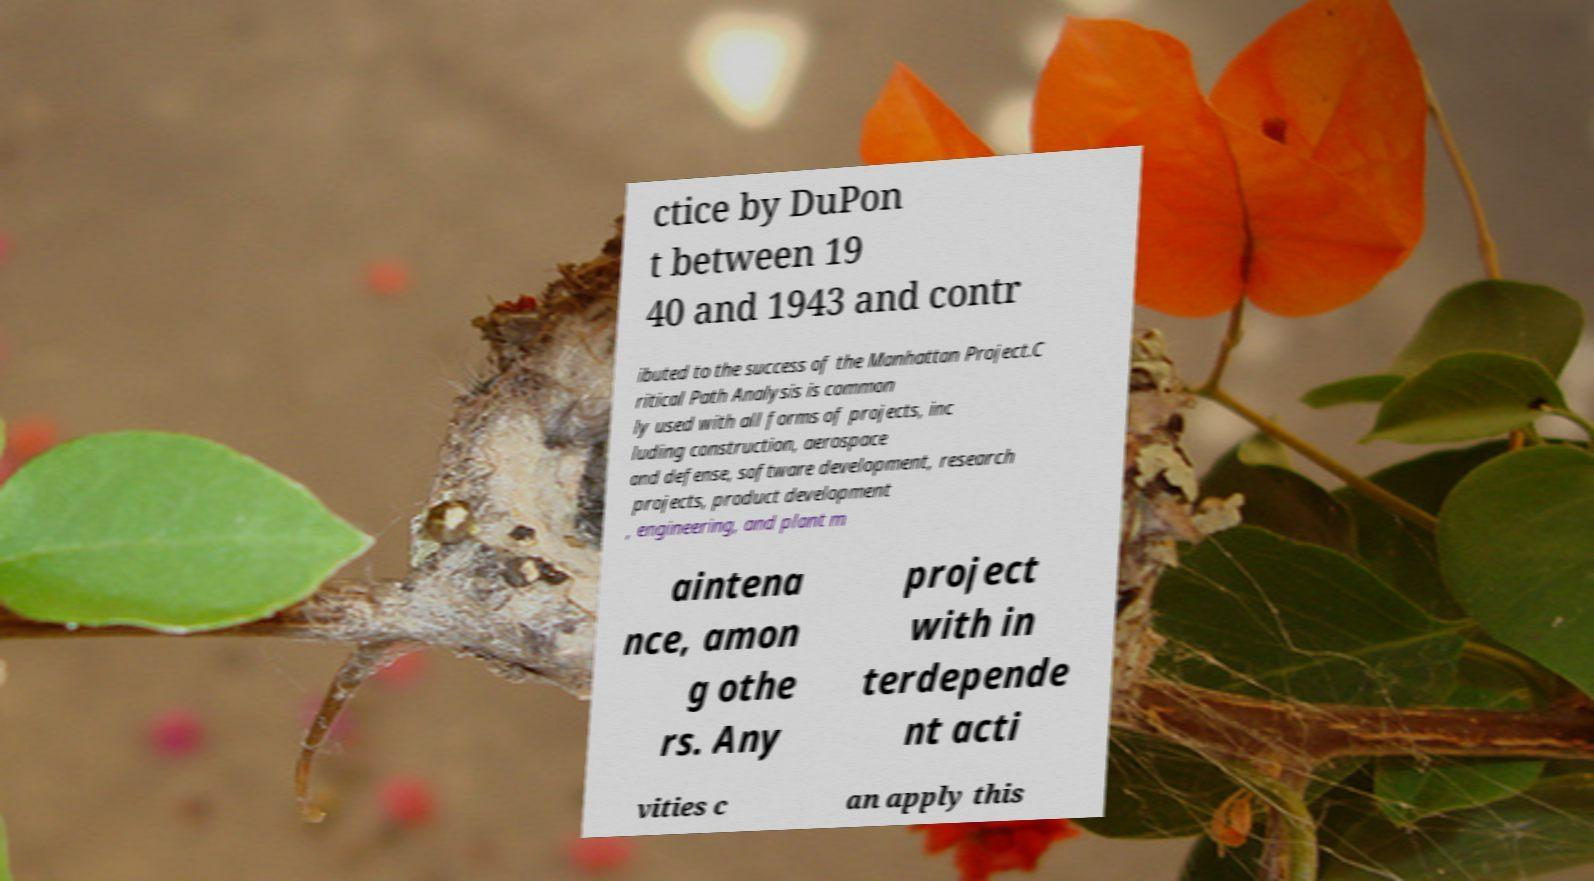Could you extract and type out the text from this image? ctice by DuPon t between 19 40 and 1943 and contr ibuted to the success of the Manhattan Project.C ritical Path Analysis is common ly used with all forms of projects, inc luding construction, aerospace and defense, software development, research projects, product development , engineering, and plant m aintena nce, amon g othe rs. Any project with in terdepende nt acti vities c an apply this 